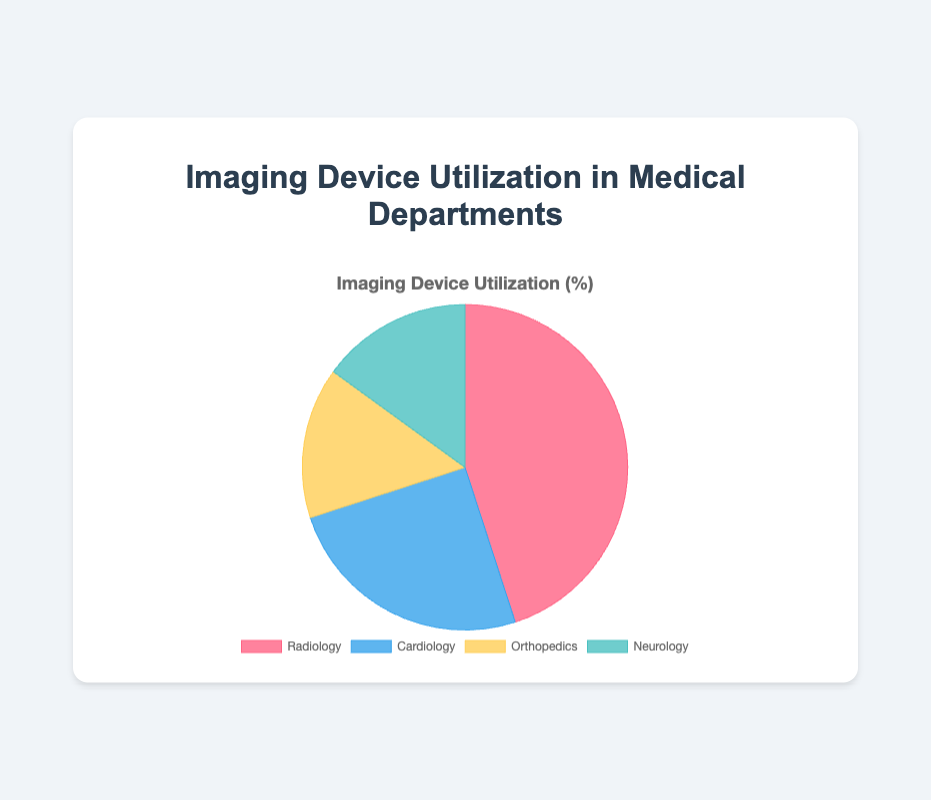Which department has the highest utilization percentage? By looking at the slices of the pie chart and their respective labels, we can see that Radiology has the highest utilization percentage. Radiology accounts for 45% of the total utilization.
Answer: Radiology What is the combined utilization percentage of Orthopedics and Neurology? Add the utilization percentages for Orthopedics (15%) and Neurology (15%). The combined utilization is 15% + 15% = 30%.
Answer: 30% How does Cardiology's utilization percentage compare to that of Neurology? Cardiology's utilization percentage is given as 25%, while Neurology's is 15%. Comparing the two, Cardiology's utilization percentage is higher.
Answer: Cardiology's utilization is higher Which slices of the pie chart have the same utilization percentage? By examining the chart, we can see that both Orthopedics and Neurology have the same utilization percentage of 15%.
Answer: Orthopedics and Neurology What percentage of the pie chart does Radiology account for? The slice labeled for Radiology represents 45% of the pie chart. This is directly indicated by the label associated with the Radiology section.
Answer: 45% If you sum up the utilization percentages of Radiology and Cardiology, what do you get? The utilization for Radiology is 45%, and for Cardiology, it is 25%. Adding them together gives 45% + 25% = 70%.
Answer: 70% Which department has the least utilization percentage and what is it? By looking at the sizes of the slices and their labels, we can see that both Orthopedics and Neurology have the lowest utilization percentage, each with 15%.
Answer: Orthopedics and Neurology, 15% What is the difference in utilization percentage between the department with the highest and the one with the lowest utilization? The highest utilization is by Radiology at 45%, while the lowest are Orthopedics and Neurology at 15%. Subtracting the lowest from the highest gives 45% - 15% = 30%.
Answer: 30% How many departments have a utilization percentage of less than 20%? By examining the chart, we can see that Orthopedics and Neurology both have utilization percentages of 15%, which are less than 20%. So, there are 2 departments.
Answer: 2 What is the ratio of Radiology's utilization to Cardiology's utilization? Radiology has a utilization percentage of 45% and Cardiology has 25%. The ratio of Radiology's utilization to Cardiology's utilization is 45:25, which can be simplified to 9:5.
Answer: 9:5 